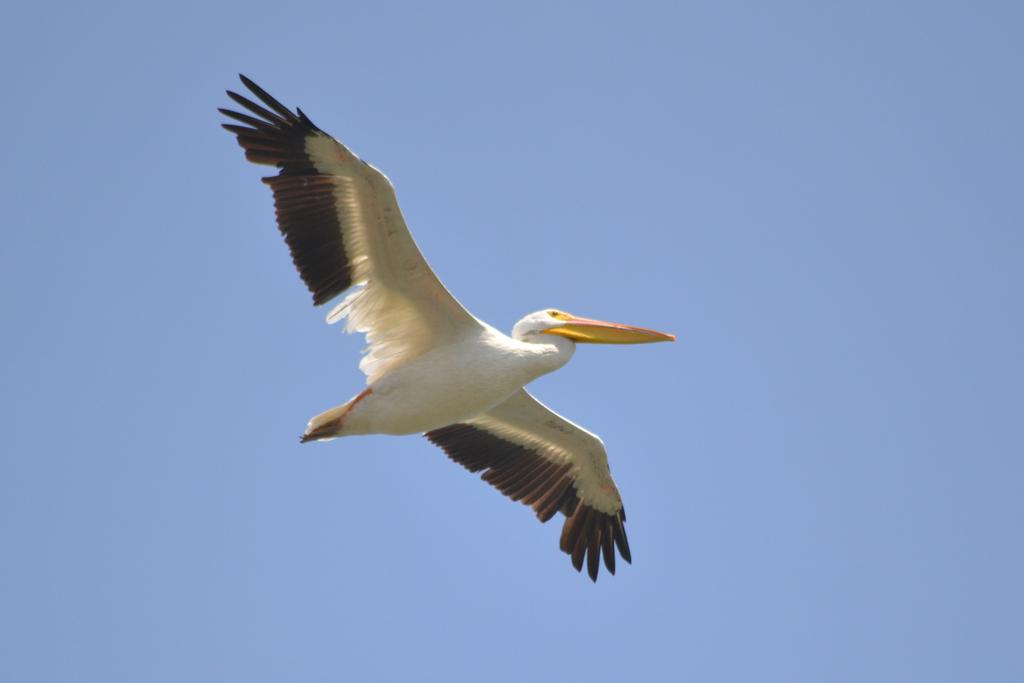What type of animal can be seen in the image? There is a bird in the image. What is the bird doing in the image? The bird is flying in the sky. How many birds are in the flock that is visible at the dock in the image? There is no flock or dock present in the image; it only features a bird flying in the sky. 